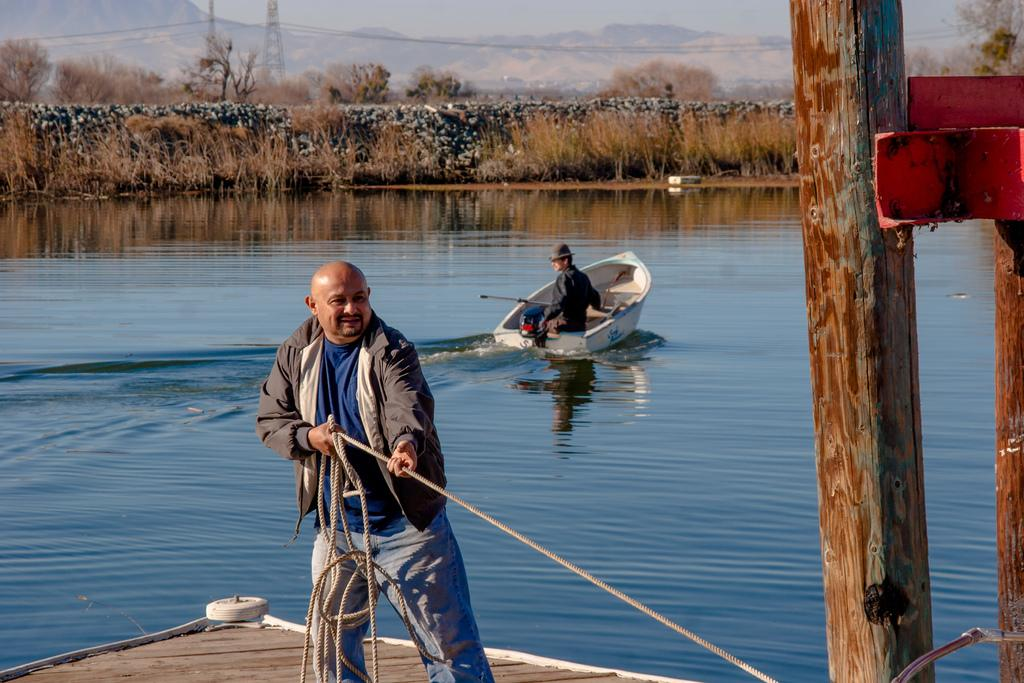What is the man in the image holding? The man in the image is holding a rope. What can be seen in the water in the image? There is a person riding a boat in the water. What is visible in the background of the image? Trees, a tower, a mountain, and the sky are visible in the background of the image. Where is the queen sitting in the image? There is no queen present in the image. What type of hall can be seen in the background of the image? There is no hall visible in the image; only trees, a tower, a mountain, and the sky are present in the background. 